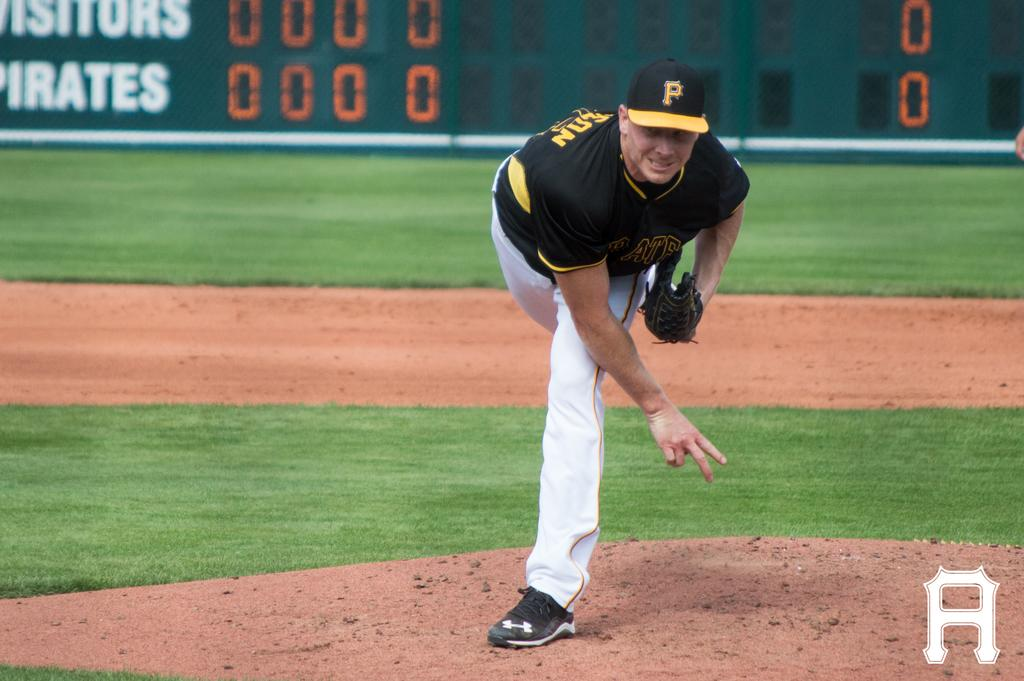Provide a one-sentence caption for the provided image. A baseball player wearing a black a yellow cap with the letter P on it. 